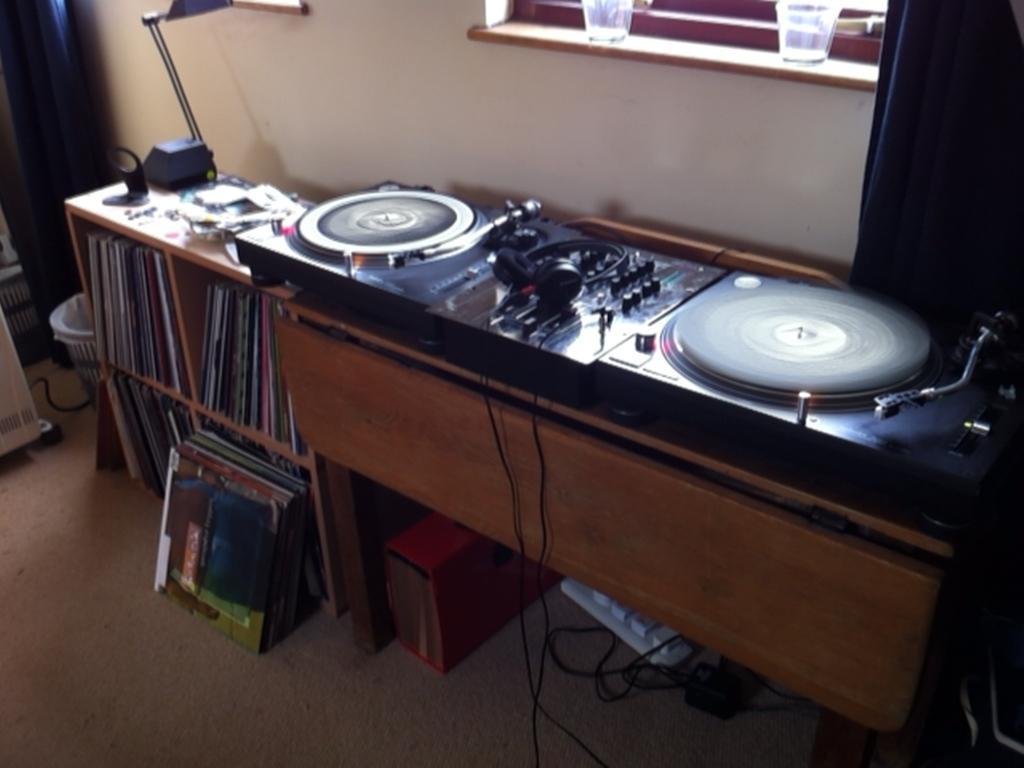Describe this image in one or two sentences. In this picture we can see musical system is placed on the table, side we can see bookshelf. 